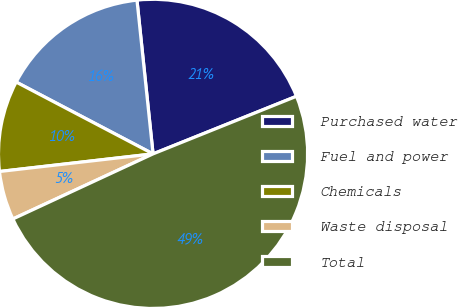Convert chart to OTSL. <chart><loc_0><loc_0><loc_500><loc_500><pie_chart><fcel>Purchased water<fcel>Fuel and power<fcel>Chemicals<fcel>Waste disposal<fcel>Total<nl><fcel>20.58%<fcel>15.65%<fcel>9.51%<fcel>5.1%<fcel>49.16%<nl></chart> 